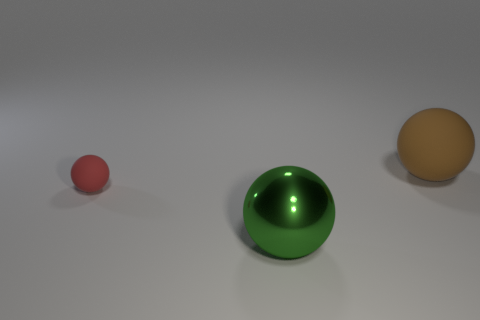There is another brown object that is made of the same material as the tiny object; what size is it?
Ensure brevity in your answer.  Large. Are there fewer cyan matte balls than red matte spheres?
Make the answer very short. Yes. There is a thing behind the small red matte object that is behind the sphere in front of the tiny thing; what is its material?
Offer a terse response. Rubber. Is the material of the large object that is in front of the red matte object the same as the large thing behind the red thing?
Offer a very short reply. No. What is the size of the object that is both on the left side of the big matte ball and on the right side of the tiny rubber sphere?
Your answer should be very brief. Large. There is a sphere that is the same size as the green metallic object; what material is it?
Ensure brevity in your answer.  Rubber. There is a rubber sphere left of the large thing to the left of the large brown matte ball; how many large green metallic balls are left of it?
Give a very brief answer. 0. There is a object in front of the small red rubber ball; does it have the same color as the rubber ball in front of the big rubber object?
Offer a very short reply. No. What color is the ball that is both to the right of the red matte thing and on the left side of the large brown rubber sphere?
Offer a terse response. Green. What number of other spheres have the same size as the red matte sphere?
Provide a succinct answer. 0. 